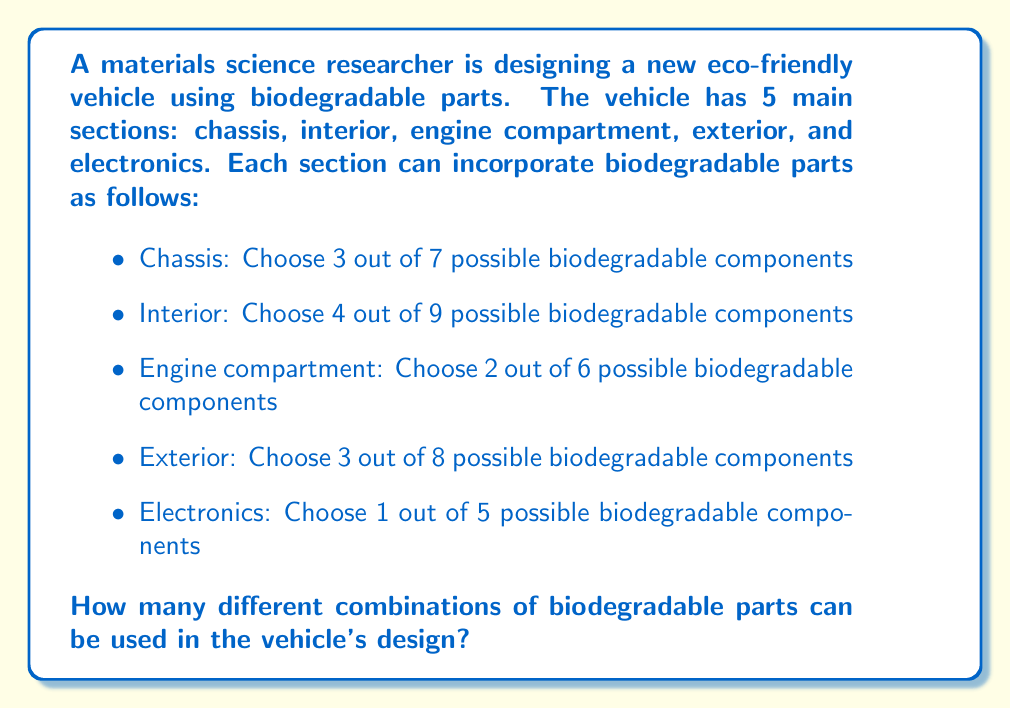Can you solve this math problem? To solve this problem, we need to use the combination formula for each section and then multiply the results together. The combination formula is:

$${n \choose k} = \frac{n!}{k!(n-k)!}$$

Where $n$ is the total number of items to choose from, and $k$ is the number of items being chosen.

Let's calculate for each section:

1. Chassis: ${7 \choose 3} = \frac{7!}{3!(7-3)!} = \frac{7!}{3!4!} = 35$

2. Interior: ${9 \choose 4} = \frac{9!}{4!(9-4)!} = \frac{9!}{4!5!} = 126$

3. Engine compartment: ${6 \choose 2} = \frac{6!}{2!(6-2)!} = \frac{6!}{2!4!} = 15$

4. Exterior: ${8 \choose 3} = \frac{8!}{3!(8-3)!} = \frac{8!}{3!5!} = 56$

5. Electronics: ${5 \choose 1} = \frac{5!}{1!(5-1)!} = \frac{5!}{1!4!} = 5$

Now, we multiply these results together to get the total number of combinations:

$$35 \times 126 \times 15 \times 56 \times 5 = 14,817,000$$

This gives us the total number of different combinations of biodegradable parts that can be used in the vehicle's design.
Answer: 14,817,000 